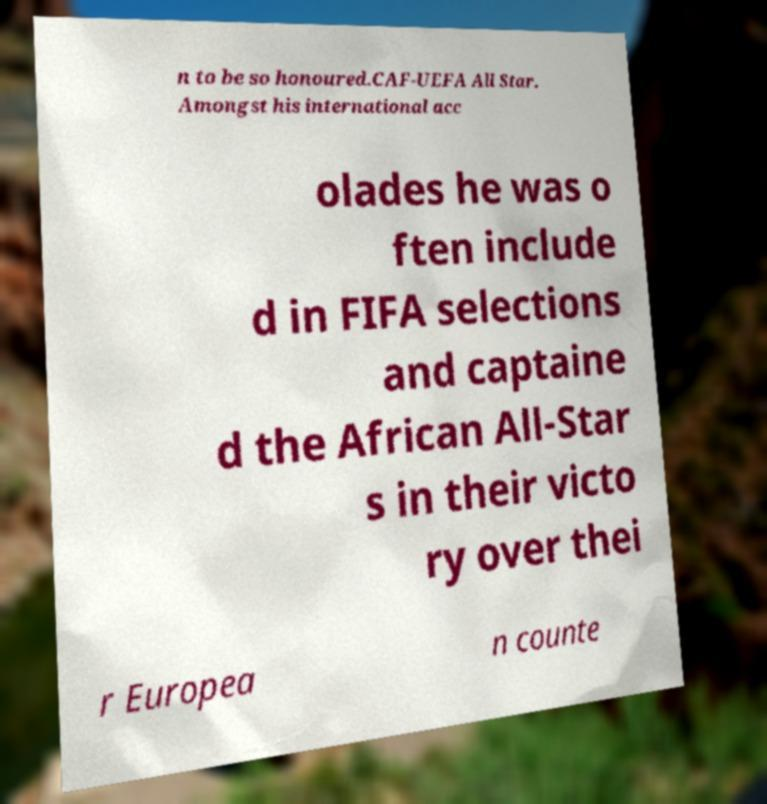Can you accurately transcribe the text from the provided image for me? n to be so honoured.CAF-UEFA All Star. Amongst his international acc olades he was o ften include d in FIFA selections and captaine d the African All-Star s in their victo ry over thei r Europea n counte 